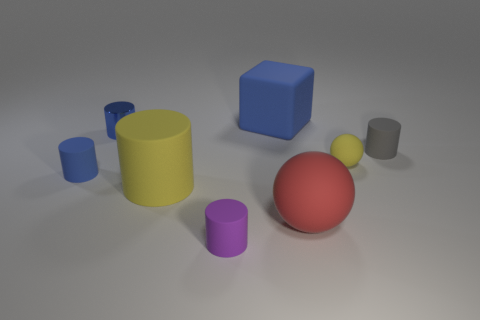What number of small gray balls are made of the same material as the gray object?
Provide a succinct answer. 0. The shiny thing that is the same shape as the gray matte thing is what size?
Provide a short and direct response. Small. Does the red matte ball have the same size as the shiny cylinder?
Your response must be concise. No. What shape is the tiny matte thing in front of the blue matte thing that is in front of the yellow matte object to the right of the red sphere?
Your answer should be very brief. Cylinder. The other object that is the same shape as the red object is what color?
Ensure brevity in your answer.  Yellow. There is a cylinder that is left of the yellow matte cylinder and in front of the tiny gray matte thing; what size is it?
Provide a succinct answer. Small. What number of purple rubber things are in front of the object in front of the matte ball that is in front of the yellow ball?
Keep it short and to the point. 0. How many big things are purple cylinders or blue cubes?
Your response must be concise. 1. Does the yellow object that is behind the large yellow rubber cylinder have the same material as the large blue block?
Offer a terse response. Yes. What material is the large sphere in front of the small rubber cylinder on the left side of the small blue cylinder that is behind the yellow rubber ball?
Ensure brevity in your answer.  Rubber. 